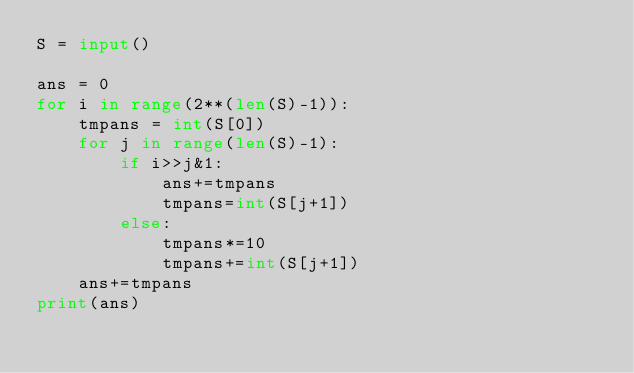<code> <loc_0><loc_0><loc_500><loc_500><_Python_>S = input()

ans = 0
for i in range(2**(len(S)-1)):
    tmpans = int(S[0])
    for j in range(len(S)-1):
        if i>>j&1:
            ans+=tmpans
            tmpans=int(S[j+1])
        else:
            tmpans*=10
            tmpans+=int(S[j+1])
    ans+=tmpans
print(ans)</code> 